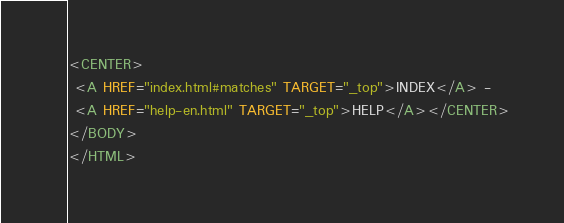Convert code to text. <code><loc_0><loc_0><loc_500><loc_500><_HTML_><CENTER>
 <A HREF="index.html#matches" TARGET="_top">INDEX</A> - 
 <A HREF="help-en.html" TARGET="_top">HELP</A></CENTER>
</BODY>
</HTML>
</code> 